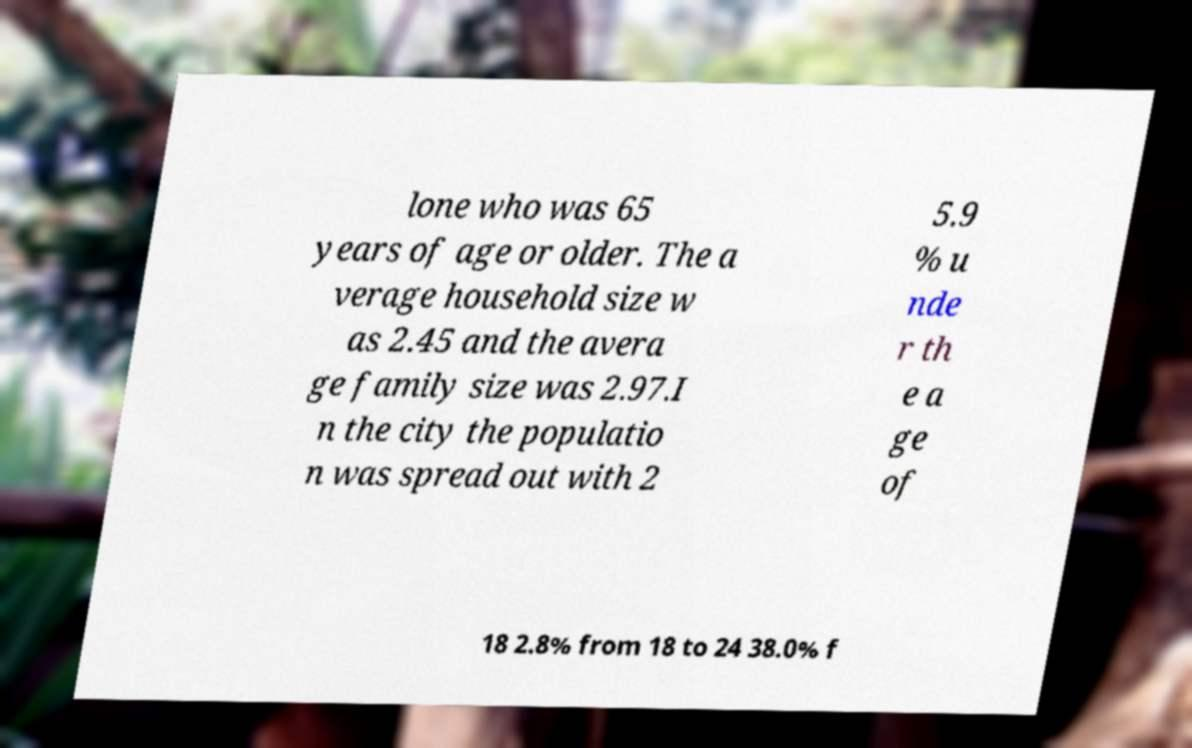What messages or text are displayed in this image? I need them in a readable, typed format. lone who was 65 years of age or older. The a verage household size w as 2.45 and the avera ge family size was 2.97.I n the city the populatio n was spread out with 2 5.9 % u nde r th e a ge of 18 2.8% from 18 to 24 38.0% f 